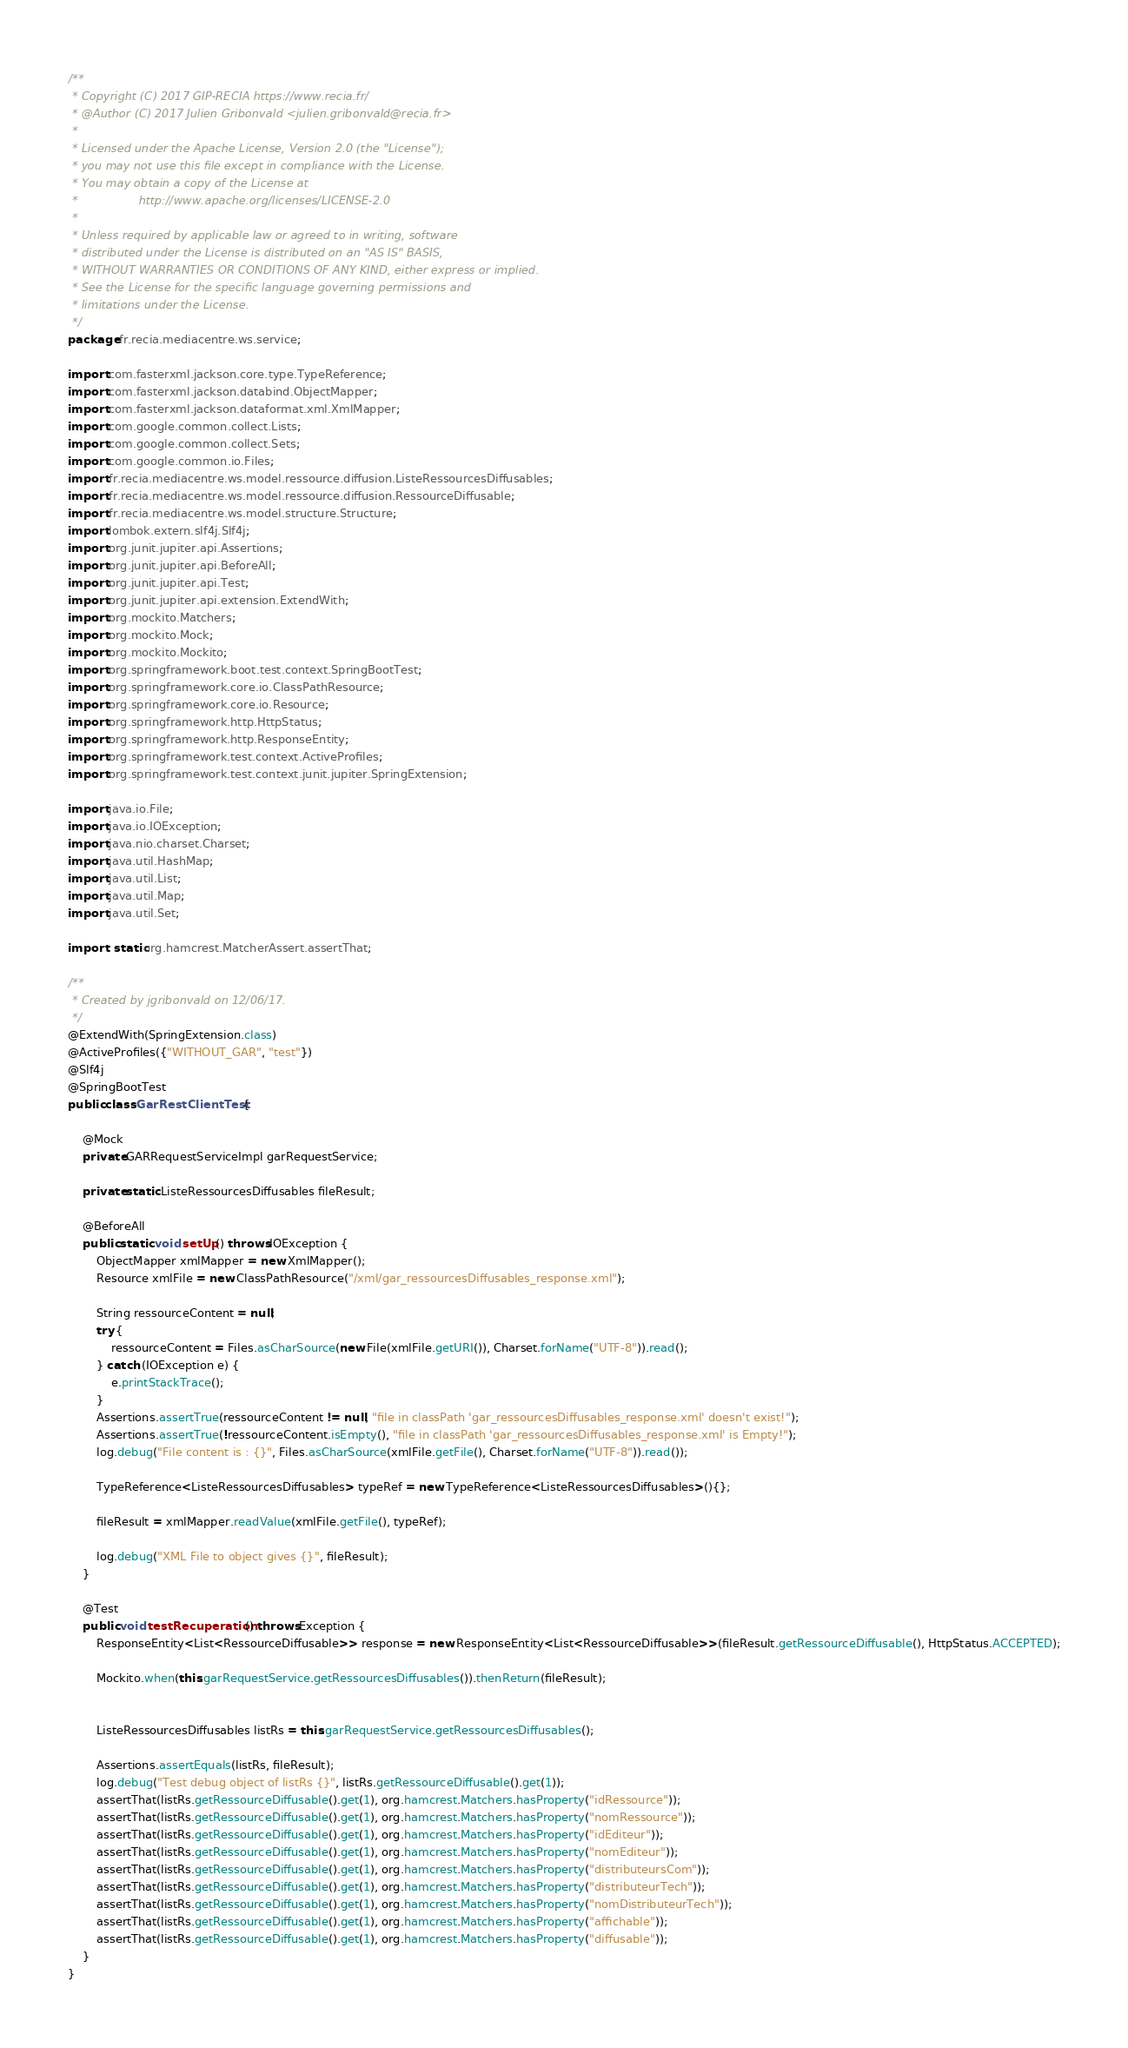Convert code to text. <code><loc_0><loc_0><loc_500><loc_500><_Java_>/**
 * Copyright (C) 2017 GIP-RECIA https://www.recia.fr/
 * @Author (C) 2017 Julien Gribonvald <julien.gribonvald@recia.fr>
 *
 * Licensed under the Apache License, Version 2.0 (the "License");
 * you may not use this file except in compliance with the License.
 * You may obtain a copy of the License at
 *                 http://www.apache.org/licenses/LICENSE-2.0
 *
 * Unless required by applicable law or agreed to in writing, software
 * distributed under the License is distributed on an "AS IS" BASIS,
 * WITHOUT WARRANTIES OR CONDITIONS OF ANY KIND, either express or implied.
 * See the License for the specific language governing permissions and
 * limitations under the License.
 */
package fr.recia.mediacentre.ws.service;

import com.fasterxml.jackson.core.type.TypeReference;
import com.fasterxml.jackson.databind.ObjectMapper;
import com.fasterxml.jackson.dataformat.xml.XmlMapper;
import com.google.common.collect.Lists;
import com.google.common.collect.Sets;
import com.google.common.io.Files;
import fr.recia.mediacentre.ws.model.ressource.diffusion.ListeRessourcesDiffusables;
import fr.recia.mediacentre.ws.model.ressource.diffusion.RessourceDiffusable;
import fr.recia.mediacentre.ws.model.structure.Structure;
import lombok.extern.slf4j.Slf4j;
import org.junit.jupiter.api.Assertions;
import org.junit.jupiter.api.BeforeAll;
import org.junit.jupiter.api.Test;
import org.junit.jupiter.api.extension.ExtendWith;
import org.mockito.Matchers;
import org.mockito.Mock;
import org.mockito.Mockito;
import org.springframework.boot.test.context.SpringBootTest;
import org.springframework.core.io.ClassPathResource;
import org.springframework.core.io.Resource;
import org.springframework.http.HttpStatus;
import org.springframework.http.ResponseEntity;
import org.springframework.test.context.ActiveProfiles;
import org.springframework.test.context.junit.jupiter.SpringExtension;

import java.io.File;
import java.io.IOException;
import java.nio.charset.Charset;
import java.util.HashMap;
import java.util.List;
import java.util.Map;
import java.util.Set;

import static org.hamcrest.MatcherAssert.assertThat;

/**
 * Created by jgribonvald on 12/06/17.
 */
@ExtendWith(SpringExtension.class)
@ActiveProfiles({"WITHOUT_GAR", "test"})
@Slf4j
@SpringBootTest
public class GarRestClientTest {

    @Mock
    private GARRequestServiceImpl garRequestService;

    private static ListeRessourcesDiffusables fileResult;

    @BeforeAll
    public static void setUp() throws IOException {
        ObjectMapper xmlMapper = new XmlMapper();
        Resource xmlFile = new ClassPathResource("/xml/gar_ressourcesDiffusables_response.xml");

        String ressourceContent = null;
        try {
            ressourceContent = Files.asCharSource(new File(xmlFile.getURI()), Charset.forName("UTF-8")).read();
        } catch (IOException e) {
            e.printStackTrace();
        }
        Assertions.assertTrue(ressourceContent != null, "file in classPath 'gar_ressourcesDiffusables_response.xml' doesn't exist!");
        Assertions.assertTrue(!ressourceContent.isEmpty(), "file in classPath 'gar_ressourcesDiffusables_response.xml' is Empty!");
        log.debug("File content is : {}", Files.asCharSource(xmlFile.getFile(), Charset.forName("UTF-8")).read());

        TypeReference<ListeRessourcesDiffusables> typeRef = new TypeReference<ListeRessourcesDiffusables>(){};

        fileResult = xmlMapper.readValue(xmlFile.getFile(), typeRef);

        log.debug("XML File to object gives {}", fileResult);
    }

    @Test
    public void testRecuperation() throws Exception {
        ResponseEntity<List<RessourceDiffusable>> response = new ResponseEntity<List<RessourceDiffusable>>(fileResult.getRessourceDiffusable(), HttpStatus.ACCEPTED);

        Mockito.when(this.garRequestService.getRessourcesDiffusables()).thenReturn(fileResult);


        ListeRessourcesDiffusables listRs = this.garRequestService.getRessourcesDiffusables();

        Assertions.assertEquals(listRs, fileResult);
        log.debug("Test debug object of listRs {}", listRs.getRessourceDiffusable().get(1));
        assertThat(listRs.getRessourceDiffusable().get(1), org.hamcrest.Matchers.hasProperty("idRessource"));
        assertThat(listRs.getRessourceDiffusable().get(1), org.hamcrest.Matchers.hasProperty("nomRessource"));
        assertThat(listRs.getRessourceDiffusable().get(1), org.hamcrest.Matchers.hasProperty("idEditeur"));
        assertThat(listRs.getRessourceDiffusable().get(1), org.hamcrest.Matchers.hasProperty("nomEditeur"));
        assertThat(listRs.getRessourceDiffusable().get(1), org.hamcrest.Matchers.hasProperty("distributeursCom"));
        assertThat(listRs.getRessourceDiffusable().get(1), org.hamcrest.Matchers.hasProperty("distributeurTech"));
        assertThat(listRs.getRessourceDiffusable().get(1), org.hamcrest.Matchers.hasProperty("nomDistributeurTech"));
        assertThat(listRs.getRessourceDiffusable().get(1), org.hamcrest.Matchers.hasProperty("affichable"));
        assertThat(listRs.getRessourceDiffusable().get(1), org.hamcrest.Matchers.hasProperty("diffusable"));
    }
}
</code> 